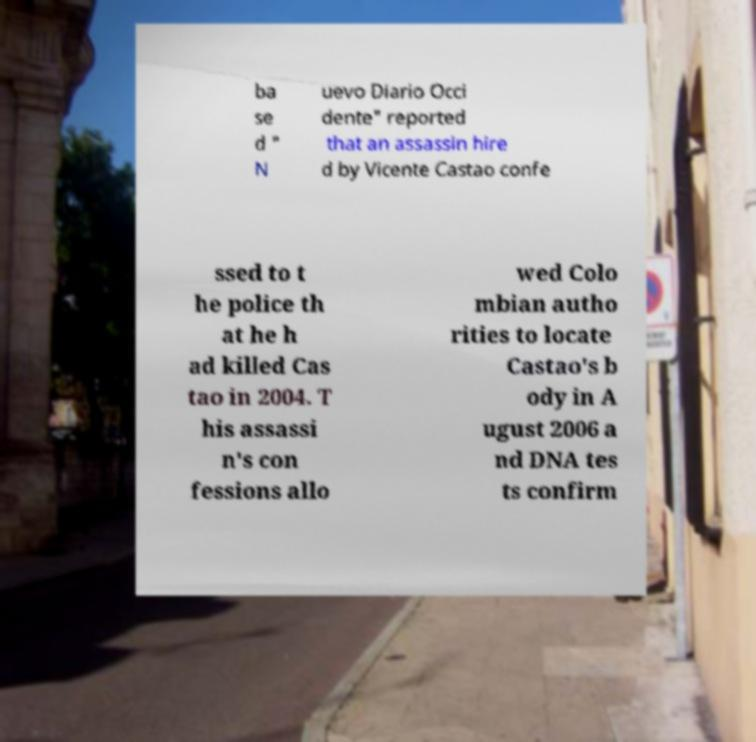For documentation purposes, I need the text within this image transcribed. Could you provide that? ba se d " N uevo Diario Occi dente" reported that an assassin hire d by Vicente Castao confe ssed to t he police th at he h ad killed Cas tao in 2004. T his assassi n's con fessions allo wed Colo mbian autho rities to locate Castao's b ody in A ugust 2006 a nd DNA tes ts confirm 